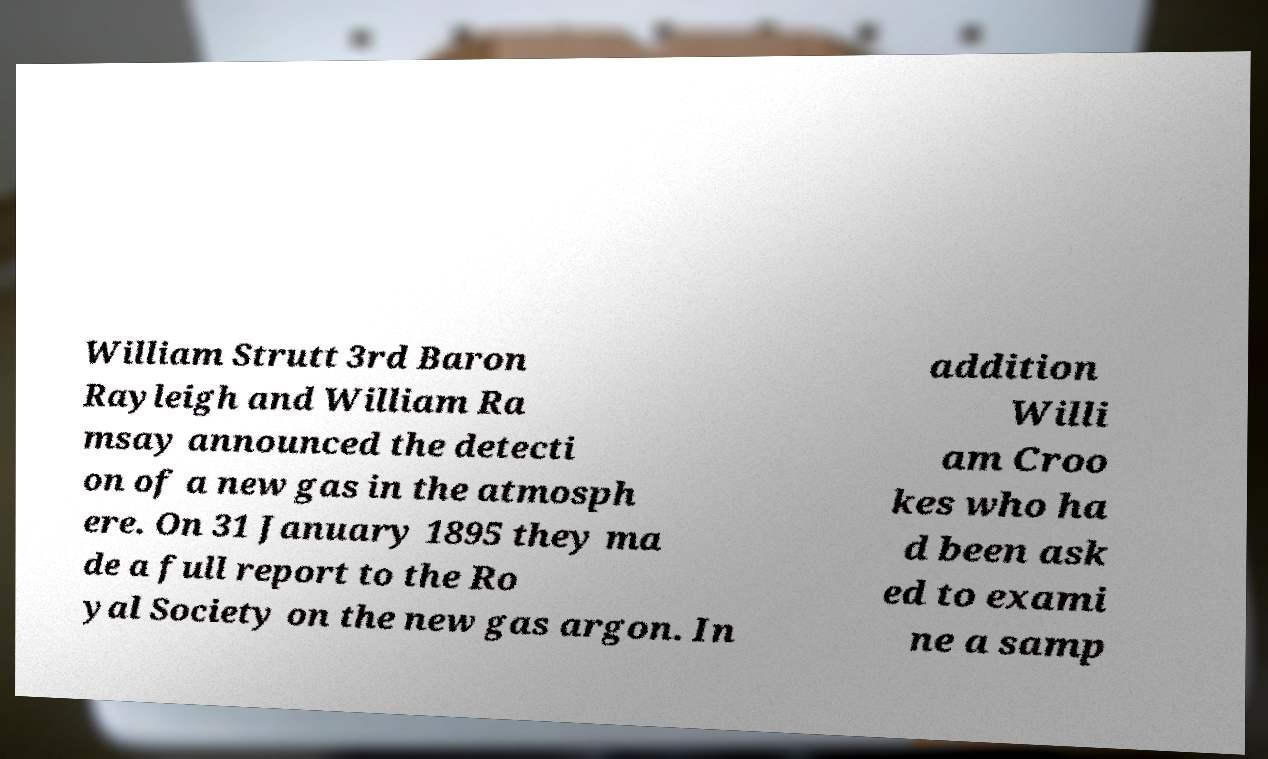Please read and relay the text visible in this image. What does it say? William Strutt 3rd Baron Rayleigh and William Ra msay announced the detecti on of a new gas in the atmosph ere. On 31 January 1895 they ma de a full report to the Ro yal Society on the new gas argon. In addition Willi am Croo kes who ha d been ask ed to exami ne a samp 